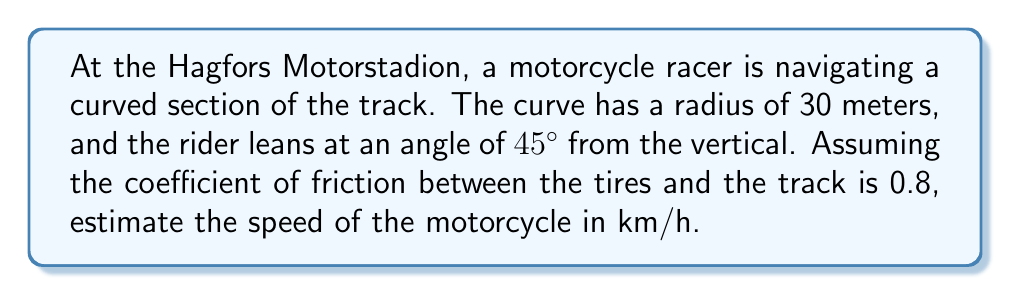Provide a solution to this math problem. To solve this problem, we'll use the concepts of centripetal force and trigonometry. Here's a step-by-step explanation:

1. In a banked turn, the forces acting on the motorcycle are:
   - Friction force ($F_f$)
   - Normal force ($N$)
   - Weight of the motorcycle and rider ($mg$)
   - Centripetal force ($F_c$)

2. The centripetal force is balanced by the horizontal components of friction and normal force:

   $$F_c = F_f \cos 45° + N \sin 45°$$

3. The vertical components of friction and normal force balance the weight:

   $$mg = N \cos 45° - F_f \sin 45°$$

4. We know that $F_f = \mu N$, where $\mu$ is the coefficient of friction (0.8 in this case).

5. The centripetal force is given by:

   $$F_c = \frac{mv^2}{r}$$

   Where $v$ is the velocity and $r$ is the radius of the curve (30 m).

6. Substituting these into the first equation:

   $$\frac{mv^2}{r} = \mu N \cos 45° + N \sin 45°$$

7. Dividing both sides by $N$:

   $$\frac{mv^2}{rN} = \mu \cos 45° + \sin 45°$$

8. From the second equation, we can derive:

   $$\frac{mg}{N} = \cos 45° - \mu \sin 45°$$

9. Dividing the first equation by the second:

   $$\frac{v^2}{rg} = \frac{\mu \cos 45° + \sin 45°}{\cos 45° - \mu \sin 45°}$$

10. Simplifying (noting that $\cos 45° = \sin 45° = \frac{1}{\sqrt{2}}$):

    $$\frac{v^2}{rg} = \frac{0.8 + 1}{1 - 0.8} = 9$$

11. Solving for $v$:

    $$v = \sqrt{9rg} = \sqrt{9 \cdot 30 \cdot 9.8} \approx 51.5 \text{ m/s}$$

12. Converting to km/h:

    $$51.5 \text{ m/s} \cdot \frac{3600 \text{ s}}{1 \text{ h}} \cdot \frac{1 \text{ km}}{1000 \text{ m}} \approx 185.4 \text{ km/h}$$
Answer: The estimated speed of the motorcycle is approximately 185.4 km/h. 